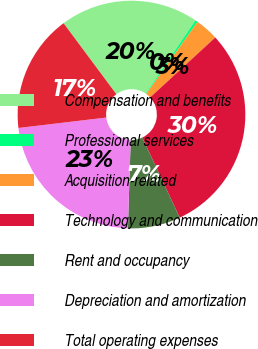<chart> <loc_0><loc_0><loc_500><loc_500><pie_chart><fcel>Compensation and benefits<fcel>Professional services<fcel>Acquisition-related<fcel>Technology and communication<fcel>Rent and occupancy<fcel>Depreciation and amortization<fcel>Total operating expenses<nl><fcel>19.67%<fcel>0.36%<fcel>3.31%<fcel>29.87%<fcel>7.47%<fcel>22.62%<fcel>16.71%<nl></chart> 